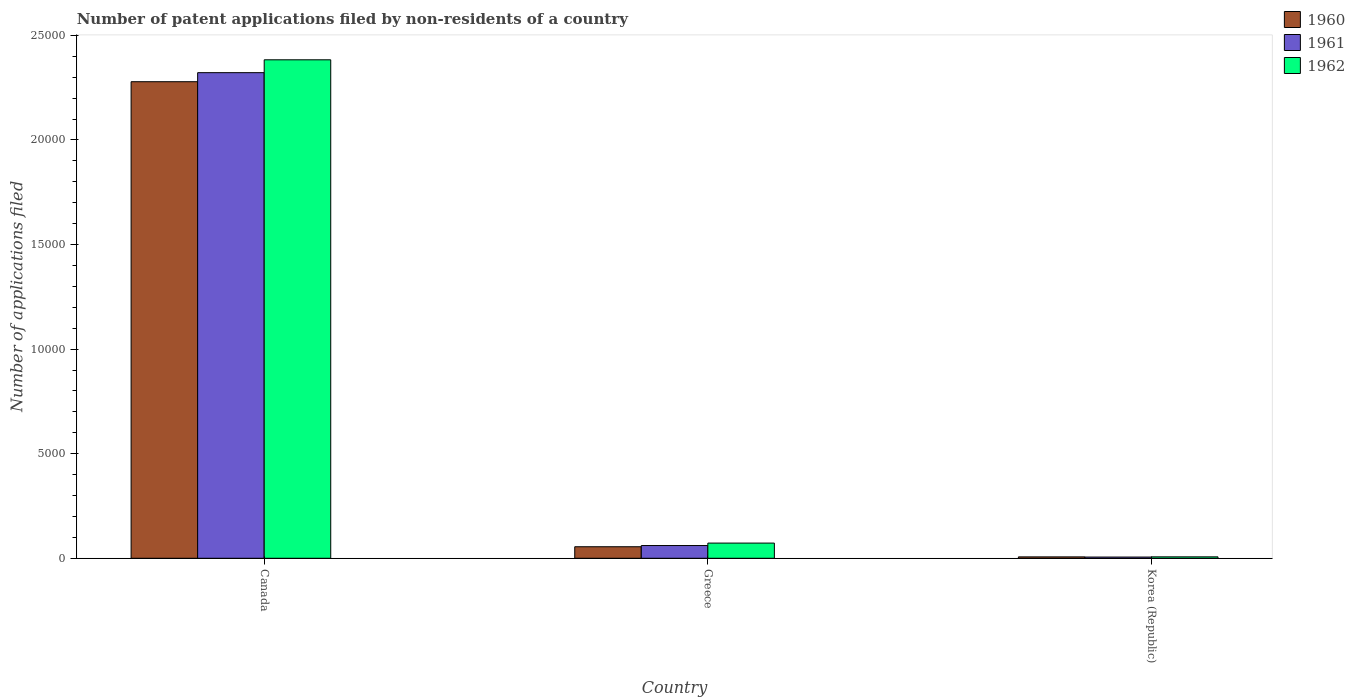How many different coloured bars are there?
Offer a very short reply. 3. How many groups of bars are there?
Provide a succinct answer. 3. How many bars are there on the 2nd tick from the left?
Ensure brevity in your answer.  3. What is the number of applications filed in 1960 in Greece?
Make the answer very short. 551. Across all countries, what is the maximum number of applications filed in 1961?
Offer a very short reply. 2.32e+04. In which country was the number of applications filed in 1961 maximum?
Your answer should be very brief. Canada. What is the total number of applications filed in 1962 in the graph?
Ensure brevity in your answer.  2.46e+04. What is the difference between the number of applications filed in 1962 in Canada and that in Greece?
Keep it short and to the point. 2.31e+04. What is the difference between the number of applications filed in 1962 in Greece and the number of applications filed in 1960 in Korea (Republic)?
Offer a very short reply. 660. What is the average number of applications filed in 1962 per country?
Offer a terse response. 8209.33. What is the difference between the number of applications filed of/in 1961 and number of applications filed of/in 1962 in Greece?
Your response must be concise. -117. What is the ratio of the number of applications filed in 1961 in Canada to that in Korea (Republic)?
Provide a succinct answer. 400.33. Is the number of applications filed in 1960 in Greece less than that in Korea (Republic)?
Your answer should be very brief. No. Is the difference between the number of applications filed in 1961 in Canada and Greece greater than the difference between the number of applications filed in 1962 in Canada and Greece?
Give a very brief answer. No. What is the difference between the highest and the second highest number of applications filed in 1961?
Your answer should be very brief. 551. What is the difference between the highest and the lowest number of applications filed in 1960?
Ensure brevity in your answer.  2.27e+04. In how many countries, is the number of applications filed in 1960 greater than the average number of applications filed in 1960 taken over all countries?
Keep it short and to the point. 1. Is the sum of the number of applications filed in 1960 in Canada and Greece greater than the maximum number of applications filed in 1961 across all countries?
Provide a short and direct response. Yes. What does the 1st bar from the left in Korea (Republic) represents?
Your answer should be compact. 1960. Is it the case that in every country, the sum of the number of applications filed in 1962 and number of applications filed in 1961 is greater than the number of applications filed in 1960?
Give a very brief answer. Yes. How many countries are there in the graph?
Provide a succinct answer. 3. What is the difference between two consecutive major ticks on the Y-axis?
Provide a succinct answer. 5000. Does the graph contain any zero values?
Make the answer very short. No. Where does the legend appear in the graph?
Offer a very short reply. Top right. How many legend labels are there?
Give a very brief answer. 3. What is the title of the graph?
Offer a very short reply. Number of patent applications filed by non-residents of a country. Does "2012" appear as one of the legend labels in the graph?
Offer a very short reply. No. What is the label or title of the Y-axis?
Provide a short and direct response. Number of applications filed. What is the Number of applications filed in 1960 in Canada?
Give a very brief answer. 2.28e+04. What is the Number of applications filed of 1961 in Canada?
Offer a very short reply. 2.32e+04. What is the Number of applications filed of 1962 in Canada?
Your answer should be very brief. 2.38e+04. What is the Number of applications filed of 1960 in Greece?
Offer a terse response. 551. What is the Number of applications filed of 1961 in Greece?
Provide a succinct answer. 609. What is the Number of applications filed in 1962 in Greece?
Ensure brevity in your answer.  726. What is the Number of applications filed in 1960 in Korea (Republic)?
Provide a succinct answer. 66. What is the Number of applications filed in 1962 in Korea (Republic)?
Give a very brief answer. 68. Across all countries, what is the maximum Number of applications filed of 1960?
Your response must be concise. 2.28e+04. Across all countries, what is the maximum Number of applications filed of 1961?
Your answer should be compact. 2.32e+04. Across all countries, what is the maximum Number of applications filed in 1962?
Provide a succinct answer. 2.38e+04. Across all countries, what is the minimum Number of applications filed of 1960?
Ensure brevity in your answer.  66. Across all countries, what is the minimum Number of applications filed in 1962?
Offer a very short reply. 68. What is the total Number of applications filed in 1960 in the graph?
Offer a very short reply. 2.34e+04. What is the total Number of applications filed in 1961 in the graph?
Ensure brevity in your answer.  2.39e+04. What is the total Number of applications filed of 1962 in the graph?
Make the answer very short. 2.46e+04. What is the difference between the Number of applications filed in 1960 in Canada and that in Greece?
Give a very brief answer. 2.22e+04. What is the difference between the Number of applications filed in 1961 in Canada and that in Greece?
Your response must be concise. 2.26e+04. What is the difference between the Number of applications filed of 1962 in Canada and that in Greece?
Offer a very short reply. 2.31e+04. What is the difference between the Number of applications filed of 1960 in Canada and that in Korea (Republic)?
Make the answer very short. 2.27e+04. What is the difference between the Number of applications filed of 1961 in Canada and that in Korea (Republic)?
Give a very brief answer. 2.32e+04. What is the difference between the Number of applications filed of 1962 in Canada and that in Korea (Republic)?
Provide a short and direct response. 2.38e+04. What is the difference between the Number of applications filed of 1960 in Greece and that in Korea (Republic)?
Your answer should be compact. 485. What is the difference between the Number of applications filed in 1961 in Greece and that in Korea (Republic)?
Your response must be concise. 551. What is the difference between the Number of applications filed of 1962 in Greece and that in Korea (Republic)?
Your response must be concise. 658. What is the difference between the Number of applications filed of 1960 in Canada and the Number of applications filed of 1961 in Greece?
Make the answer very short. 2.22e+04. What is the difference between the Number of applications filed in 1960 in Canada and the Number of applications filed in 1962 in Greece?
Your answer should be very brief. 2.21e+04. What is the difference between the Number of applications filed of 1961 in Canada and the Number of applications filed of 1962 in Greece?
Your answer should be very brief. 2.25e+04. What is the difference between the Number of applications filed in 1960 in Canada and the Number of applications filed in 1961 in Korea (Republic)?
Provide a short and direct response. 2.27e+04. What is the difference between the Number of applications filed in 1960 in Canada and the Number of applications filed in 1962 in Korea (Republic)?
Keep it short and to the point. 2.27e+04. What is the difference between the Number of applications filed of 1961 in Canada and the Number of applications filed of 1962 in Korea (Republic)?
Your answer should be compact. 2.32e+04. What is the difference between the Number of applications filed of 1960 in Greece and the Number of applications filed of 1961 in Korea (Republic)?
Provide a short and direct response. 493. What is the difference between the Number of applications filed in 1960 in Greece and the Number of applications filed in 1962 in Korea (Republic)?
Your answer should be compact. 483. What is the difference between the Number of applications filed of 1961 in Greece and the Number of applications filed of 1962 in Korea (Republic)?
Provide a succinct answer. 541. What is the average Number of applications filed in 1960 per country?
Keep it short and to the point. 7801. What is the average Number of applications filed in 1961 per country?
Offer a very short reply. 7962. What is the average Number of applications filed of 1962 per country?
Provide a short and direct response. 8209.33. What is the difference between the Number of applications filed in 1960 and Number of applications filed in 1961 in Canada?
Provide a succinct answer. -433. What is the difference between the Number of applications filed in 1960 and Number of applications filed in 1962 in Canada?
Your answer should be compact. -1048. What is the difference between the Number of applications filed in 1961 and Number of applications filed in 1962 in Canada?
Give a very brief answer. -615. What is the difference between the Number of applications filed in 1960 and Number of applications filed in 1961 in Greece?
Offer a terse response. -58. What is the difference between the Number of applications filed in 1960 and Number of applications filed in 1962 in Greece?
Keep it short and to the point. -175. What is the difference between the Number of applications filed of 1961 and Number of applications filed of 1962 in Greece?
Offer a terse response. -117. What is the difference between the Number of applications filed in 1960 and Number of applications filed in 1962 in Korea (Republic)?
Offer a terse response. -2. What is the ratio of the Number of applications filed of 1960 in Canada to that in Greece?
Your response must be concise. 41.35. What is the ratio of the Number of applications filed of 1961 in Canada to that in Greece?
Provide a short and direct response. 38.13. What is the ratio of the Number of applications filed in 1962 in Canada to that in Greece?
Give a very brief answer. 32.83. What is the ratio of the Number of applications filed in 1960 in Canada to that in Korea (Republic)?
Offer a very short reply. 345.24. What is the ratio of the Number of applications filed in 1961 in Canada to that in Korea (Republic)?
Offer a terse response. 400.33. What is the ratio of the Number of applications filed in 1962 in Canada to that in Korea (Republic)?
Your answer should be compact. 350.5. What is the ratio of the Number of applications filed of 1960 in Greece to that in Korea (Republic)?
Your answer should be very brief. 8.35. What is the ratio of the Number of applications filed of 1961 in Greece to that in Korea (Republic)?
Your answer should be compact. 10.5. What is the ratio of the Number of applications filed in 1962 in Greece to that in Korea (Republic)?
Provide a short and direct response. 10.68. What is the difference between the highest and the second highest Number of applications filed in 1960?
Provide a short and direct response. 2.22e+04. What is the difference between the highest and the second highest Number of applications filed in 1961?
Your answer should be very brief. 2.26e+04. What is the difference between the highest and the second highest Number of applications filed of 1962?
Provide a succinct answer. 2.31e+04. What is the difference between the highest and the lowest Number of applications filed in 1960?
Give a very brief answer. 2.27e+04. What is the difference between the highest and the lowest Number of applications filed of 1961?
Offer a very short reply. 2.32e+04. What is the difference between the highest and the lowest Number of applications filed of 1962?
Ensure brevity in your answer.  2.38e+04. 